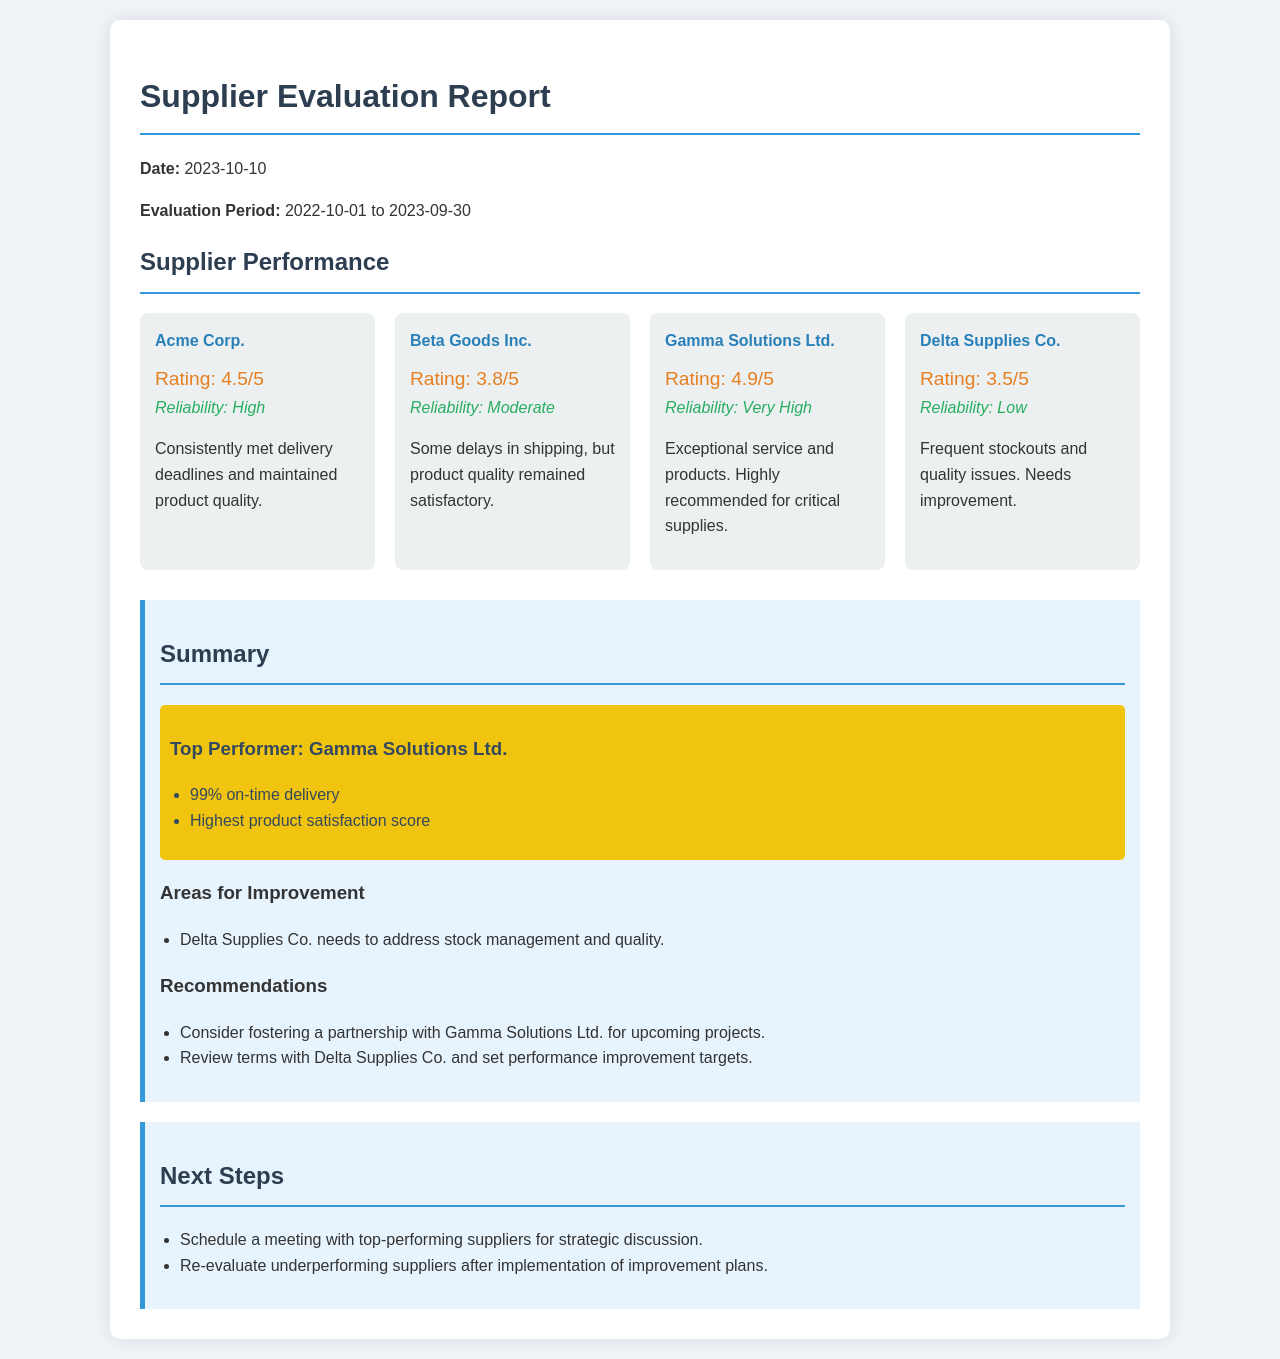What is the date of the report? The date of the report is prominently displayed at the beginning of the document.
Answer: 2023-10-10 What is the evaluation period? The evaluation period is specified right after the date in the document.
Answer: 2022-10-01 to 2023-09-30 Who is the top performer? The top performer is highlighted in the summary section of the document.
Answer: Gamma Solutions Ltd What rating did Acme Corp. receive? The rating for Acme Corp. is explicitly mentioned in the supplier performance section.
Answer: 4.5/5 What reliability assessment is given to Delta Supplies Co.? The reliability assessment for Delta Supplies Co. is noted in the supplier performance section.
Answer: Low What is one recommendation provided in the report? Recommendations are listed in the summary, which offers suggestions for supplier improvement.
Answer: Consider fostering a partnership with Gamma Solutions Ltd. for upcoming projects How many suppliers are evaluated in total? The total number of suppliers can be counted in the supplier performance section.
Answer: 4 What is the reliability rating of Gamma Solutions Ltd.? The reliability rating for Gamma Solutions Ltd. is clearly stated in the supplier performance section.
Answer: Very High What are the next steps outlined in the report? The next steps are detailed at the end of the document, outlining actions to be taken.
Answer: Schedule a meeting with top-performing suppliers for strategic discussion 